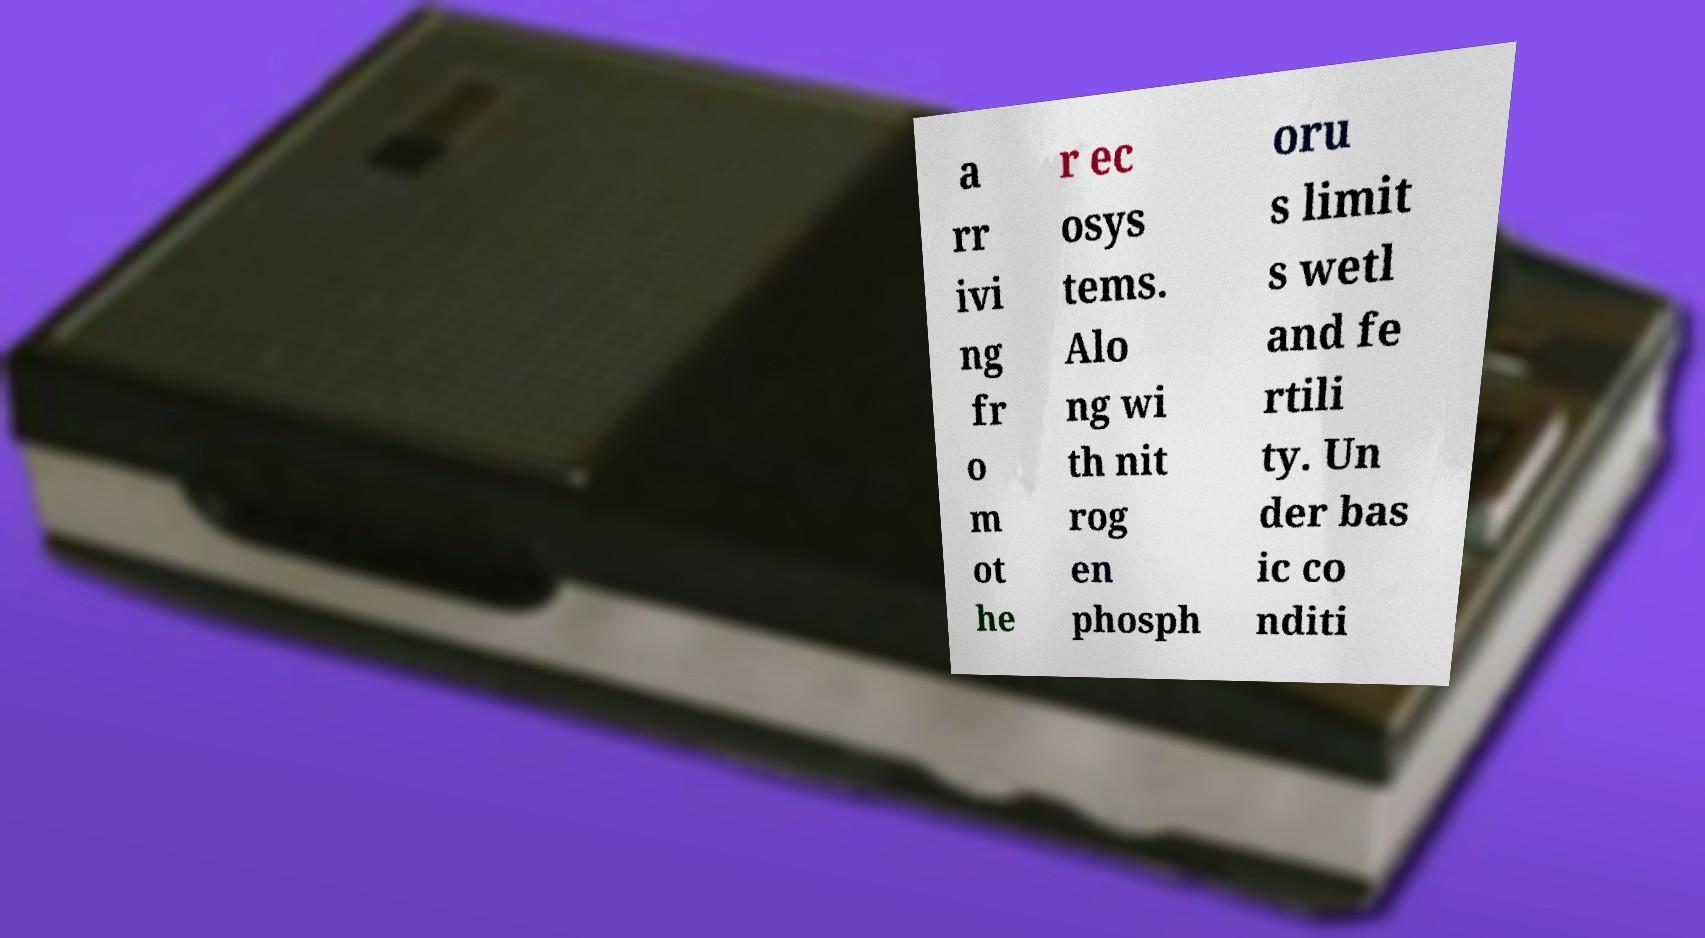For documentation purposes, I need the text within this image transcribed. Could you provide that? a rr ivi ng fr o m ot he r ec osys tems. Alo ng wi th nit rog en phosph oru s limit s wetl and fe rtili ty. Un der bas ic co nditi 